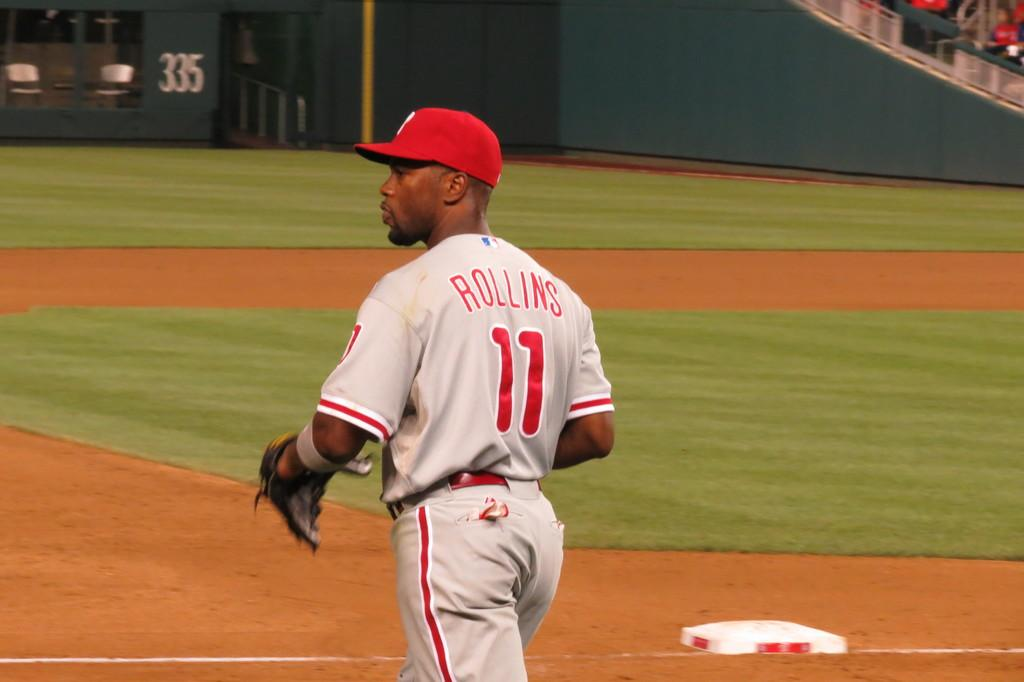<image>
Offer a succinct explanation of the picture presented. a player named Rollins on the baseball field 